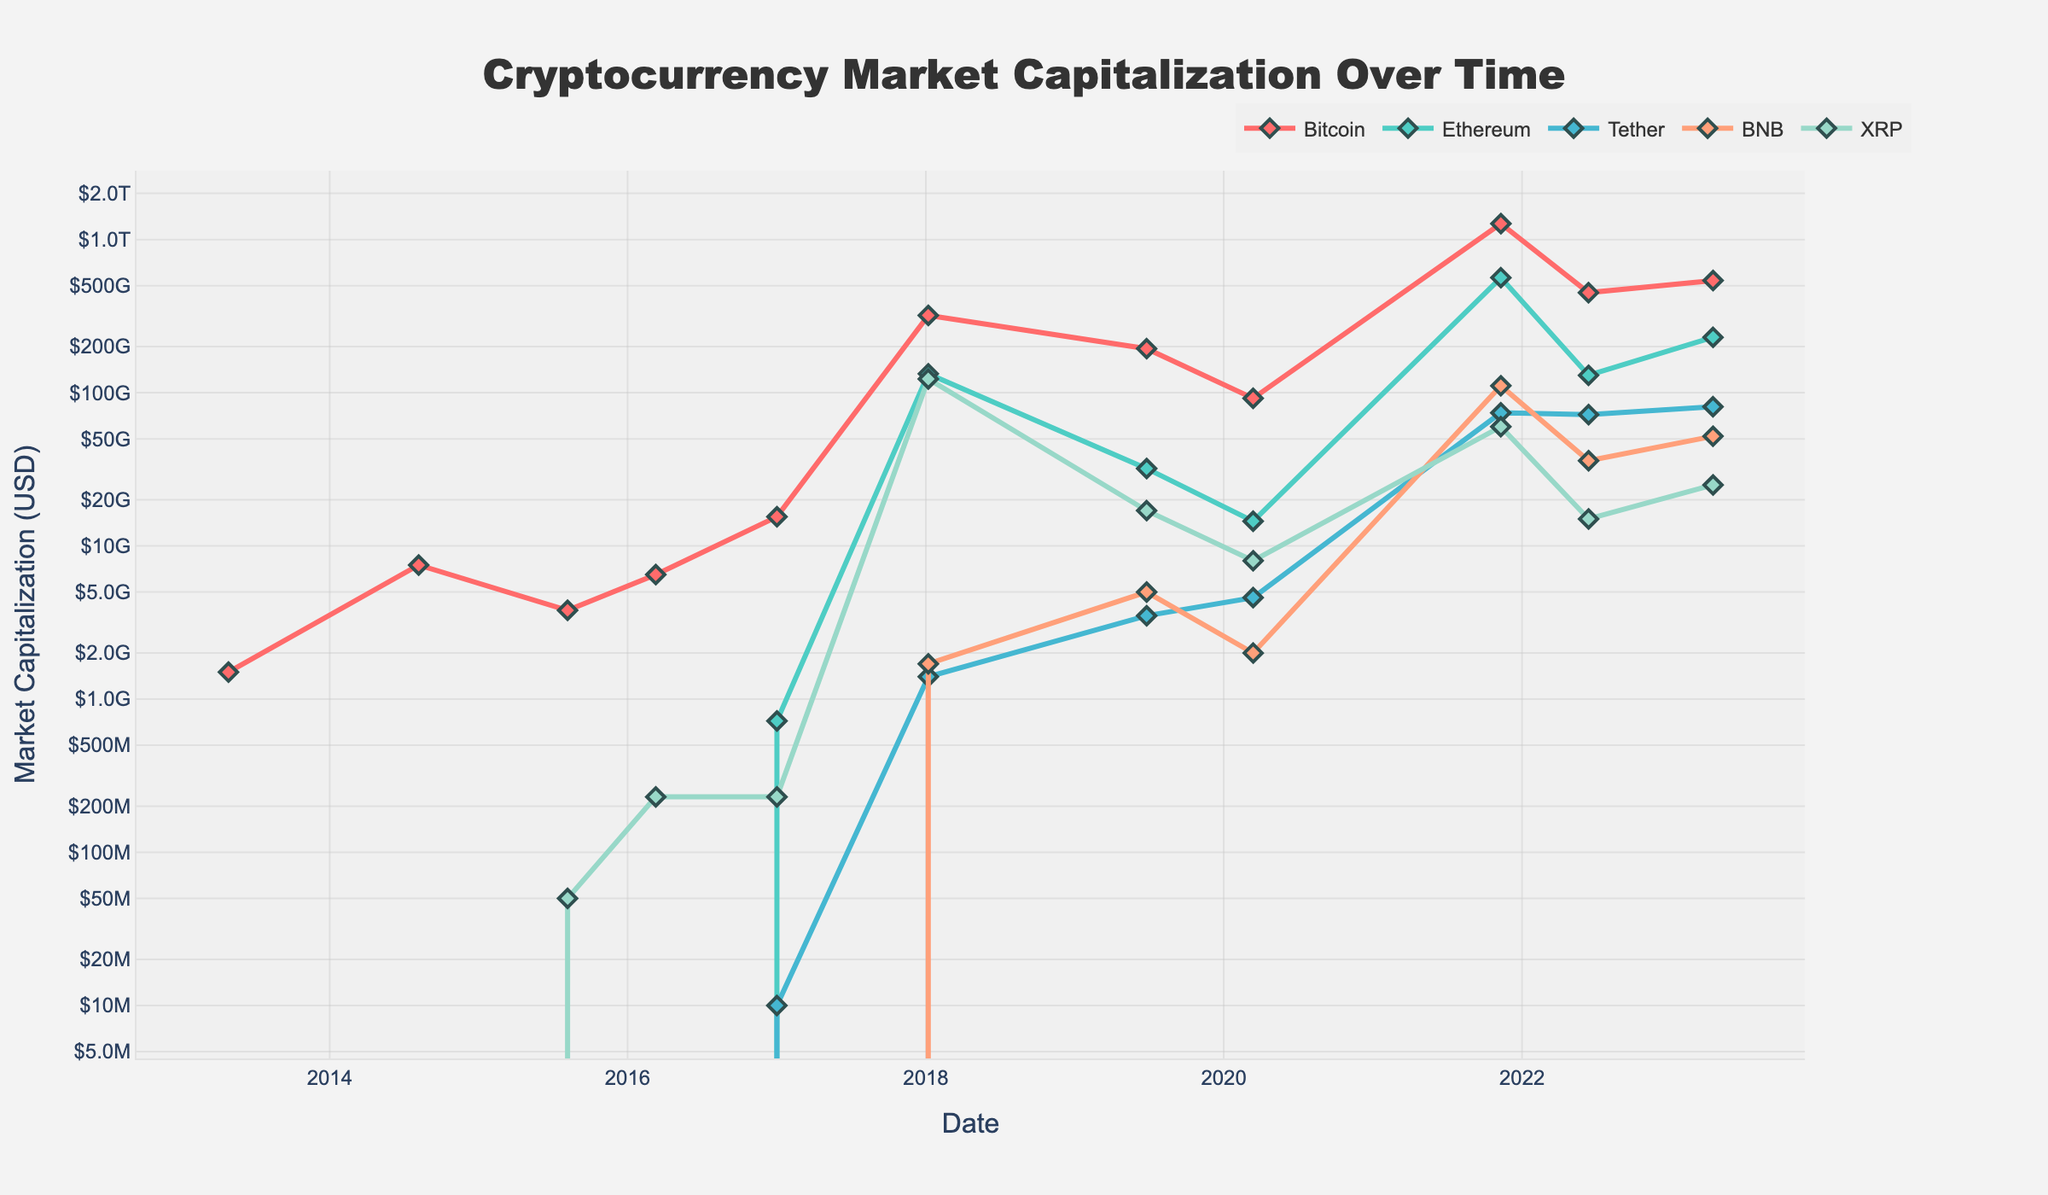What is the highest market capitalization reached by Bitcoin, and when did it occur? By looking at the Bitcoin trace on the plot, the peak value is achieved in November 2021. Check the peak point of Bitcoin and read the y-axis value and date.
Answer: \$1,270,000,000,000 in November 2021 Which cryptocurrency had the second largest market capitalization in April 2023? Locate April 2023 on the x-axis and compare the y-values of each currency. Ethereum has the second highest y-value after Bitcoin.
Answer: Ethereum How did the market capitalization of Tether change between January 2017 and November 2021? Identify the market capitalization values for Tether in January 2017 (10,000,000) and November 2021 (74,000,000,000). Subtract the earlier value from the later value.
Answer: Increased by \$73,990,000,000 Which of the top 5 cryptocurrencies had zero market capitalization at inception? Look at the values for each cryptocurrency at the earliest date (April 2013). All values except Bitcoin are zero.
Answer: Ethereum, Tether, BNB, XRP How did the market capitalization of XRP change between January 2017 and April 2023? Determine the market cap values of XRP in January 2017 (230,000,000) and April 2023 (25,000,000,000) and compute the increase.
Answer: Increased by \$24,770,000,000 In which year did Ethereum's market capitalization first surpass \$100 billion? Examine the plot for Ethereum and identify the first date where Ethereum’s y-value is greater than \$100 billion.
Answer: 2018 Which currency had an increasing trend of market capitalization over the entire period? Review the trend lines for all five currencies. Identify the one(s) that consistently increase. Note that some currencies such as Bitcoin might have fluctuations.
Answer: Tether Was there a significant drop in Bitcoin’s market capitalization between November 2021 and June 2022? How much was it? Check Bitcoin values in November 2021 (1,270,000,000,000) and June 2022 (450,000,000,000), then calculate the difference.
Answer: Yes, \$820,000,000,000 How many cryptocurrencies had a market capitalization over \$100 billion in November 2021? Examine each currency's value in November 2021 and count how many exceed \$100 billion.
Answer: Three (Bitcoin, Ethereum, XRP) Comparing Ethereum and BNB, which currency had a steeper increase in market capitalization between 2019 and 2021? Analyze the slopes of the lines corresponding to Ethereum and BNB from 2019 to 2021 to see which one is steeper.
Answer: Ethereum 